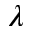Convert formula to latex. <formula><loc_0><loc_0><loc_500><loc_500>\lambda</formula> 